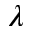Convert formula to latex. <formula><loc_0><loc_0><loc_500><loc_500>\lambda</formula> 